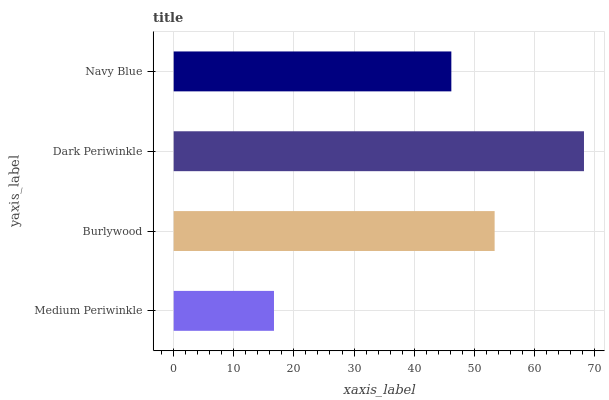Is Medium Periwinkle the minimum?
Answer yes or no. Yes. Is Dark Periwinkle the maximum?
Answer yes or no. Yes. Is Burlywood the minimum?
Answer yes or no. No. Is Burlywood the maximum?
Answer yes or no. No. Is Burlywood greater than Medium Periwinkle?
Answer yes or no. Yes. Is Medium Periwinkle less than Burlywood?
Answer yes or no. Yes. Is Medium Periwinkle greater than Burlywood?
Answer yes or no. No. Is Burlywood less than Medium Periwinkle?
Answer yes or no. No. Is Burlywood the high median?
Answer yes or no. Yes. Is Navy Blue the low median?
Answer yes or no. Yes. Is Navy Blue the high median?
Answer yes or no. No. Is Medium Periwinkle the low median?
Answer yes or no. No. 